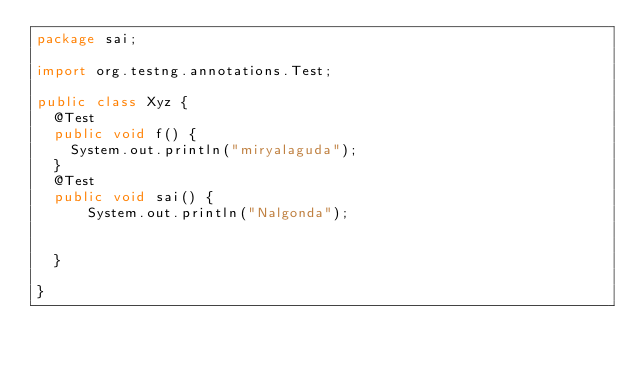Convert code to text. <code><loc_0><loc_0><loc_500><loc_500><_Java_>package sai;

import org.testng.annotations.Test;

public class Xyz {
  @Test
  public void f() {
	System.out.println("miryalaguda");
  }
  @Test
  public void sai() {
	  System.out.println("Nalgonda");
	  
	  
  }
  
}
</code> 